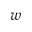<formula> <loc_0><loc_0><loc_500><loc_500>w</formula> 